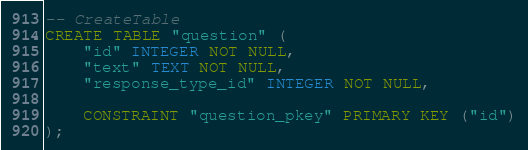Convert code to text. <code><loc_0><loc_0><loc_500><loc_500><_SQL_>-- CreateTable
CREATE TABLE "question" (
    "id" INTEGER NOT NULL,
    "text" TEXT NOT NULL,
    "response_type_id" INTEGER NOT NULL,

    CONSTRAINT "question_pkey" PRIMARY KEY ("id")
);
</code> 